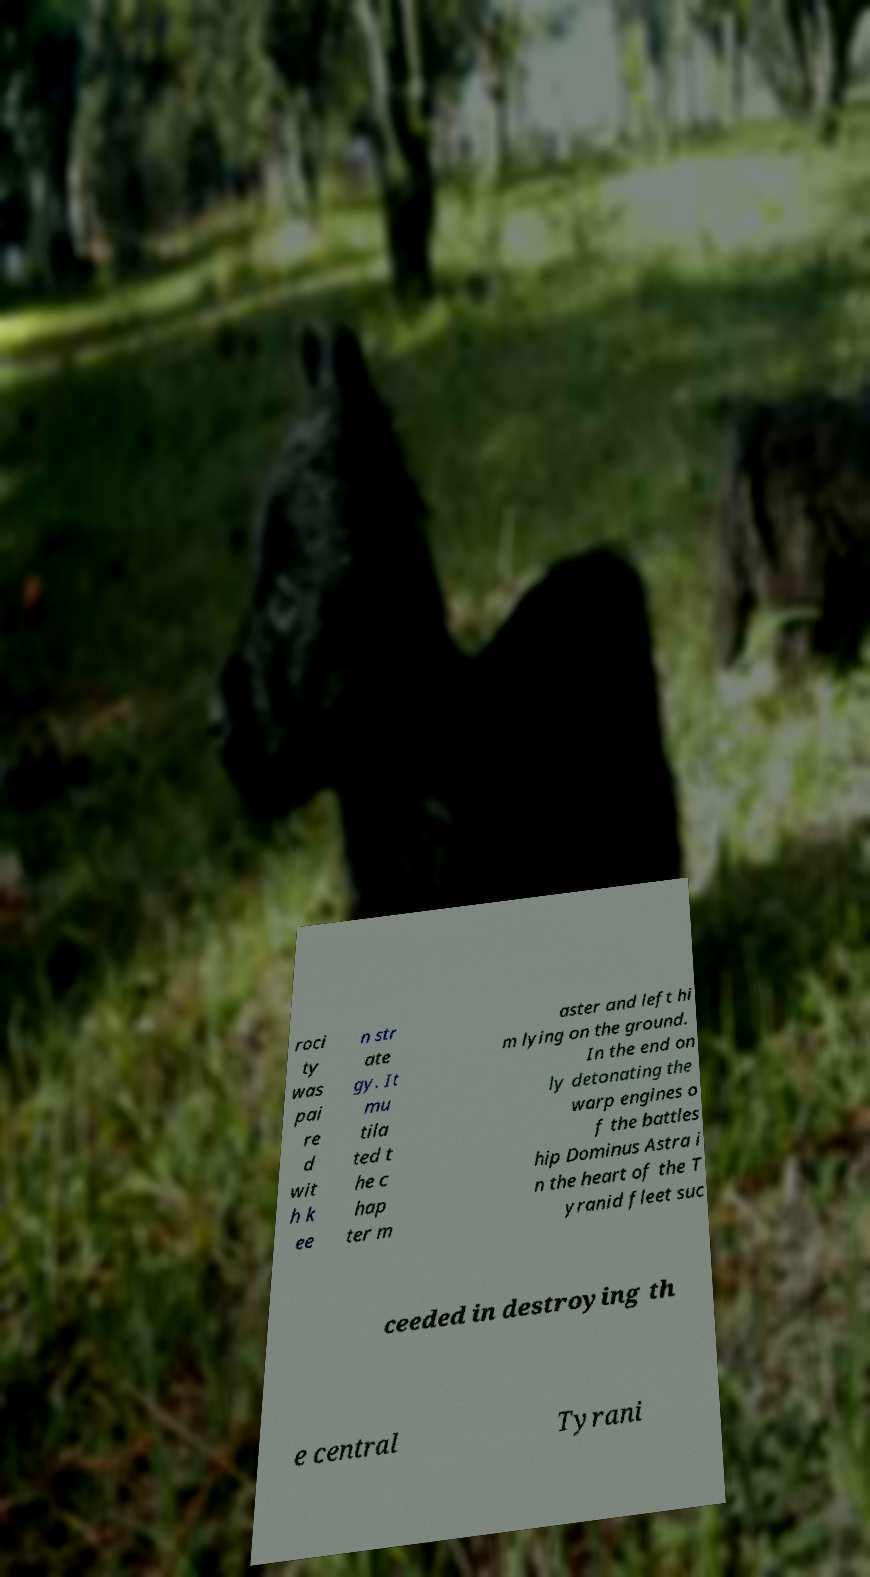What messages or text are displayed in this image? I need them in a readable, typed format. roci ty was pai re d wit h k ee n str ate gy. It mu tila ted t he c hap ter m aster and left hi m lying on the ground. In the end on ly detonating the warp engines o f the battles hip Dominus Astra i n the heart of the T yranid fleet suc ceeded in destroying th e central Tyrani 